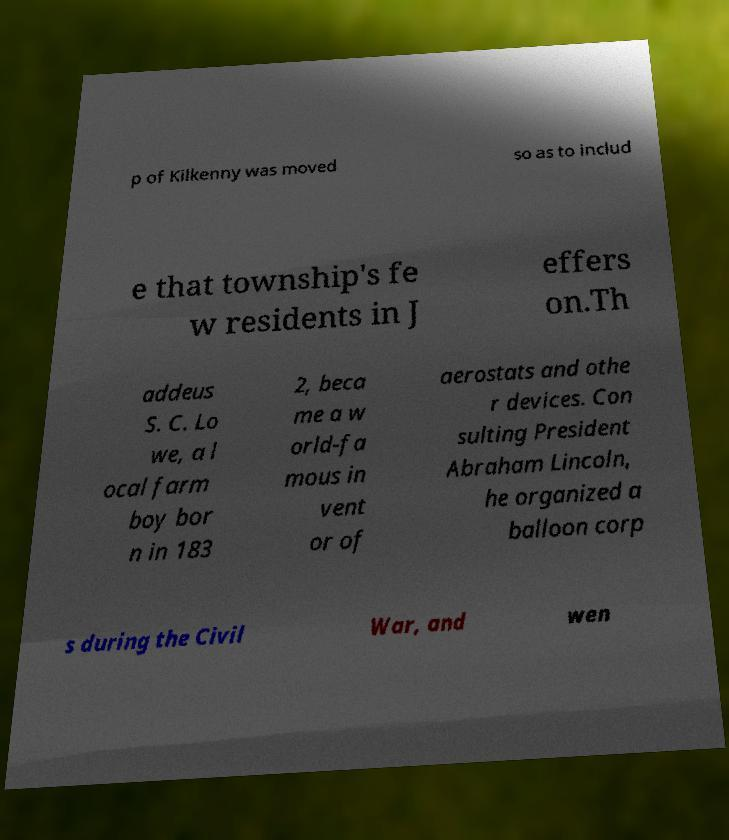I need the written content from this picture converted into text. Can you do that? p of Kilkenny was moved so as to includ e that township's fe w residents in J effers on.Th addeus S. C. Lo we, a l ocal farm boy bor n in 183 2, beca me a w orld-fa mous in vent or of aerostats and othe r devices. Con sulting President Abraham Lincoln, he organized a balloon corp s during the Civil War, and wen 